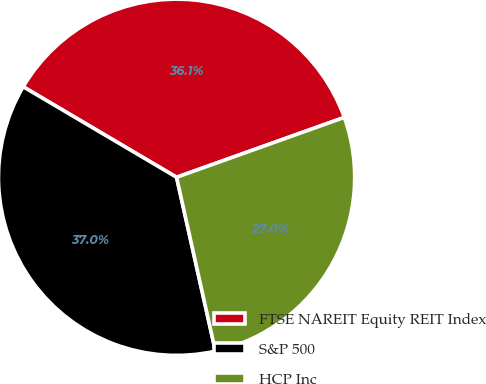Convert chart to OTSL. <chart><loc_0><loc_0><loc_500><loc_500><pie_chart><fcel>FTSE NAREIT Equity REIT Index<fcel>S&P 500<fcel>HCP Inc<nl><fcel>36.06%<fcel>36.99%<fcel>26.96%<nl></chart> 